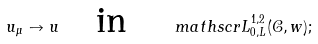Convert formula to latex. <formula><loc_0><loc_0><loc_500><loc_500>u _ { \mu } \to u \quad \text {in} \quad \ m a t h s c r { L } _ { 0 , L } ^ { 1 , 2 } ( \mathcal { C } , w ) ;</formula> 